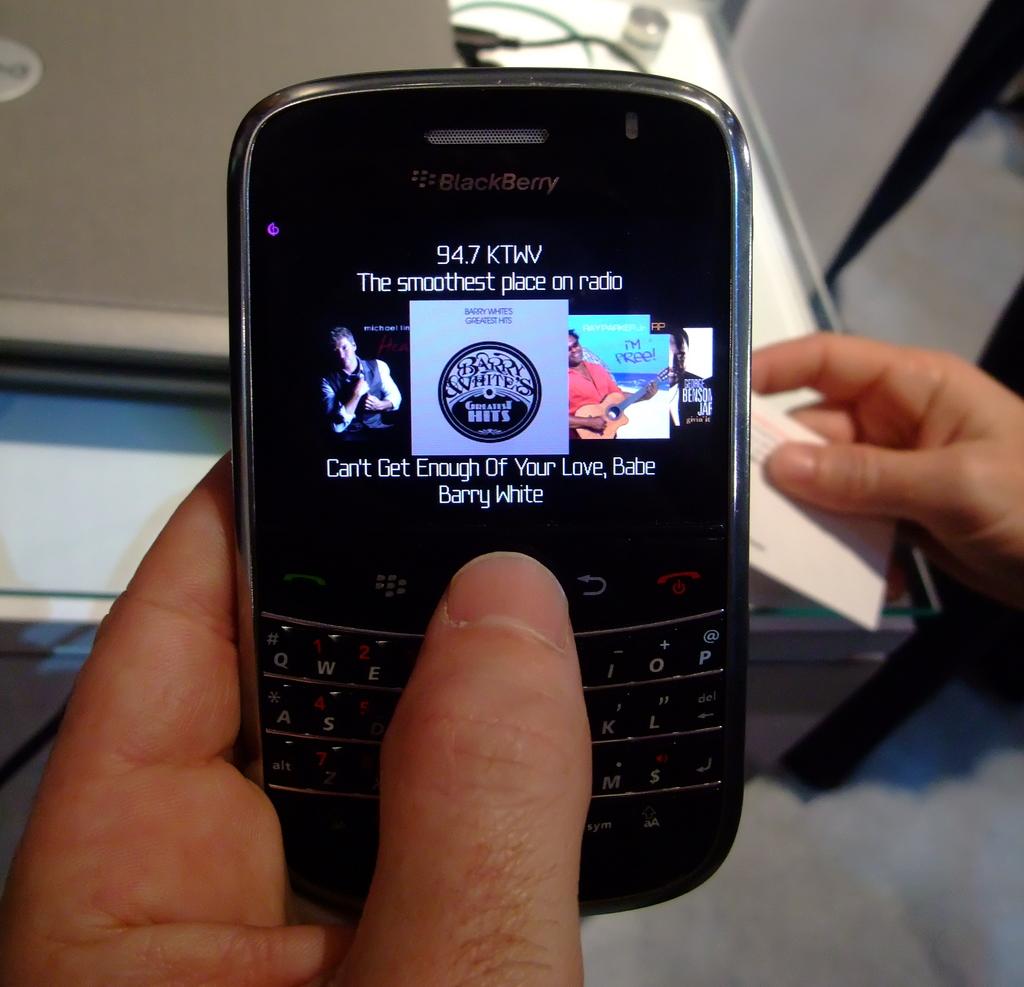What is the brand of this phone?
Offer a terse response. Blackberry. 